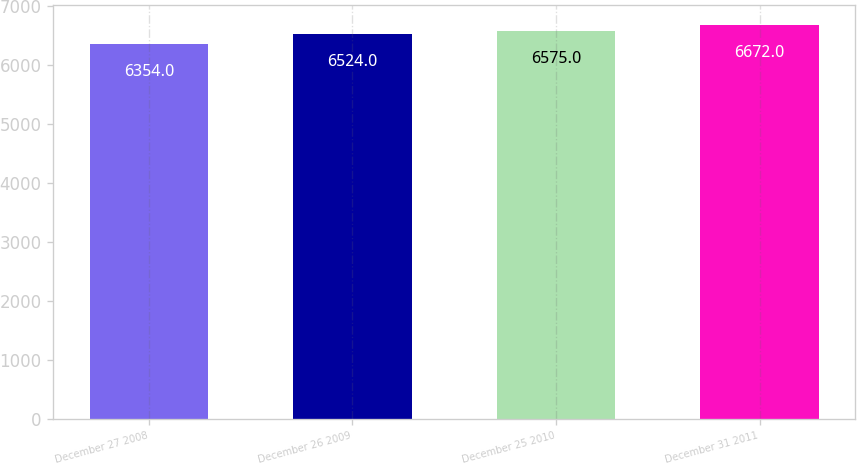Convert chart to OTSL. <chart><loc_0><loc_0><loc_500><loc_500><bar_chart><fcel>December 27 2008<fcel>December 26 2009<fcel>December 25 2010<fcel>December 31 2011<nl><fcel>6354<fcel>6524<fcel>6575<fcel>6672<nl></chart> 